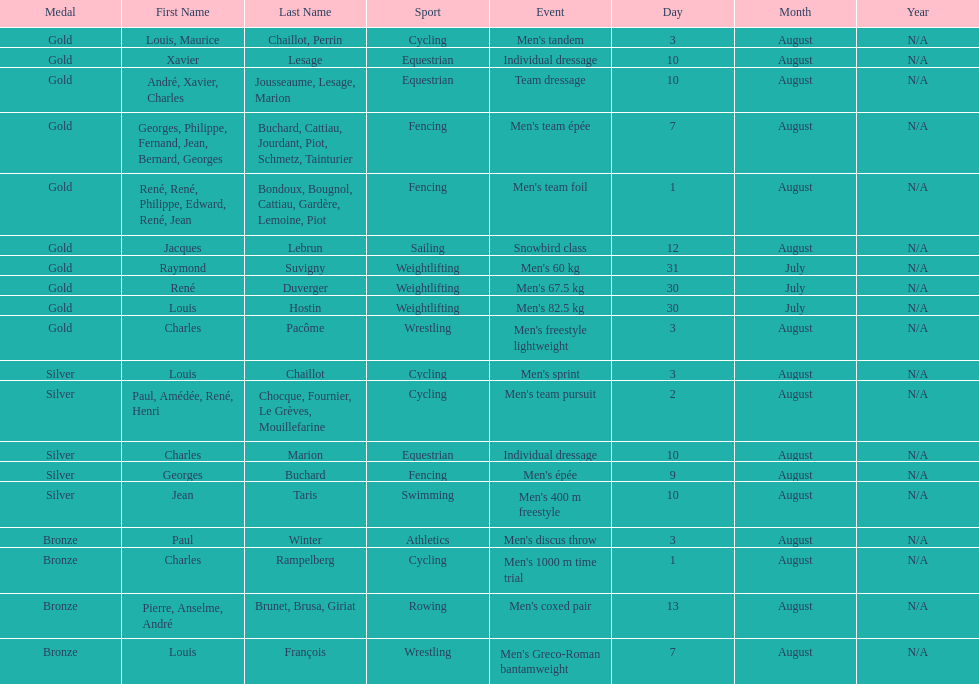What sport did louis challiot win the same medal as paul chocque in? Cycling. 